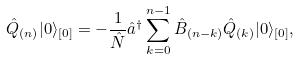Convert formula to latex. <formula><loc_0><loc_0><loc_500><loc_500>\hat { Q } _ { ( n ) } | 0 \rangle _ { [ 0 ] } = - \frac { 1 } { \hat { N } } \hat { a } ^ { \dagger } \sum _ { k = 0 } ^ { n - 1 } \hat { B } _ { ( n - k ) } \hat { Q } _ { ( k ) } | 0 \rangle _ { [ 0 ] } ,</formula> 